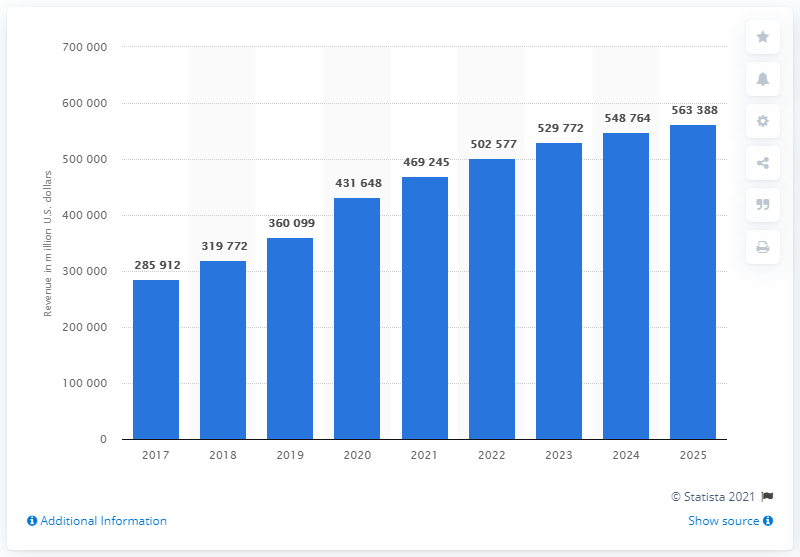Highlight a few significant elements in this photo. The revenue generated from e-commerce in the United States in 2020 was approximately 431,648. In 2017, the amount of e-commerce revenue in the USA was the lowest among all the years. The total amount of e-commerce revenue from 2017 to 2018 was 605,684. By 2025, the estimated revenue from e-commerce in the United States is expected to be approximately 563,388. 